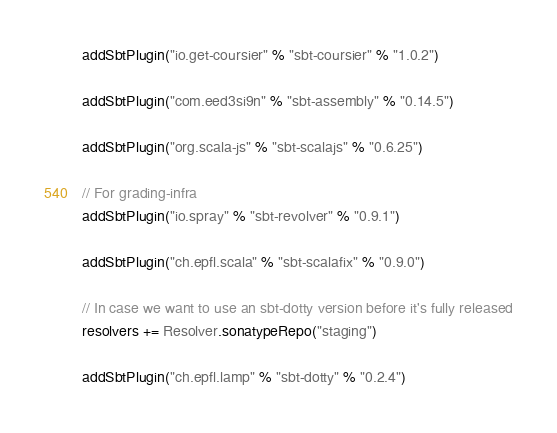Convert code to text. <code><loc_0><loc_0><loc_500><loc_500><_Scala_>addSbtPlugin("io.get-coursier" % "sbt-coursier" % "1.0.2")

addSbtPlugin("com.eed3si9n" % "sbt-assembly" % "0.14.5")

addSbtPlugin("org.scala-js" % "sbt-scalajs" % "0.6.25")

// For grading-infra
addSbtPlugin("io.spray" % "sbt-revolver" % "0.9.1")

addSbtPlugin("ch.epfl.scala" % "sbt-scalafix" % "0.9.0")

// In case we want to use an sbt-dotty version before it's fully released
resolvers += Resolver.sonatypeRepo("staging")

addSbtPlugin("ch.epfl.lamp" % "sbt-dotty" % "0.2.4")
</code> 